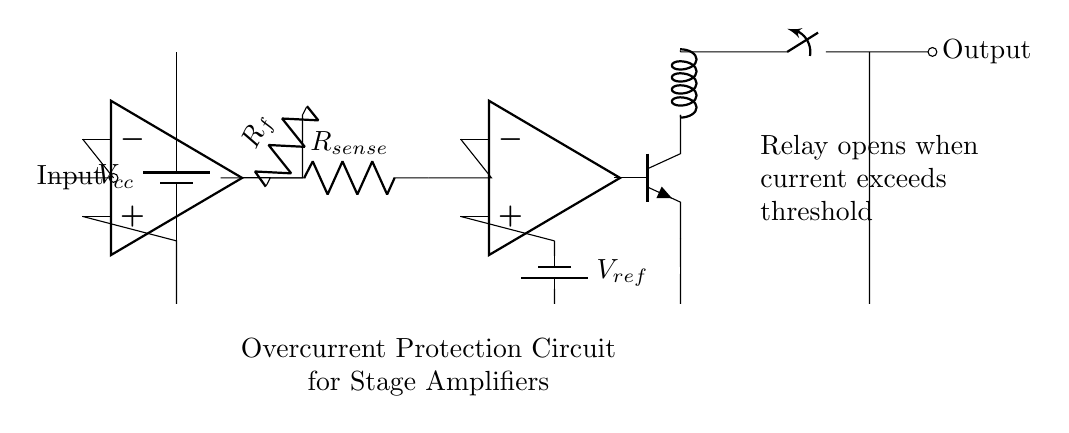What is the role of the relay in this circuit? The relay opens the circuit when the current exceeds a certain threshold, as indicated by the label next to the output, which says "Relay opens when current exceeds threshold."
Answer: opens circuit What component is used for feedback in the amplifier section? The feedback resistor, labeled R_f, connects the output of the amplifier back to its input, which helps to control the gain of the amplifier.
Answer: R_f What happens to the transistor when the comparator's output is high? When the comparator's output is high, the transistor turns on, allowing current to flow through it, which is necessary for activating the relay.
Answer: Turns on What is the purpose of the current sensing resistor? The current sensing resistor, labeled R_sense, is used to measure the current flowing through the circuit, providing feedback to the comparator for overcurrent detection.
Answer: Measure current What is the reference voltage used in this circuit? The reference voltage is provided by the battery labeled V_ref, which the comparator uses to determine when the current is too high.
Answer: V_ref How is the input to the amplifier indicated in the diagram? The input to the amplifier is indicated by the short line labeled "Input," which connects to the non-inverting terminal of the op-amp.
Answer: Input 